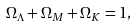Convert formula to latex. <formula><loc_0><loc_0><loc_500><loc_500>\Omega _ { \Lambda } + \Omega _ { M } + \Omega _ { K } = 1 ,</formula> 